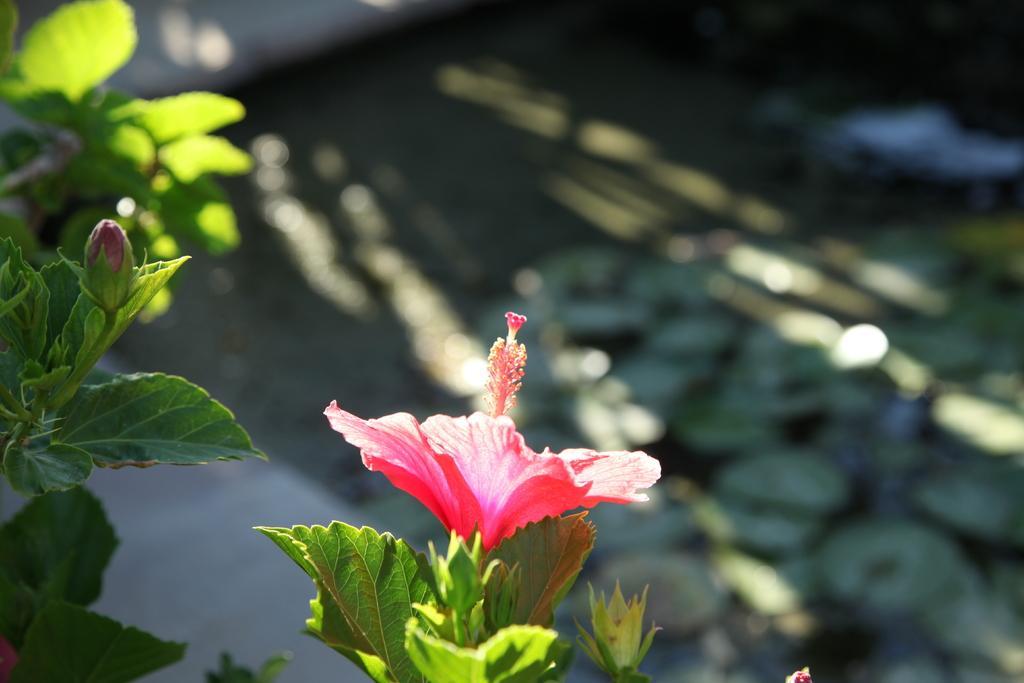Can you describe this image briefly? In the picture we can see some plants with a flower to it which is red in color and we can also see a flower bud and behind it we can see some plants which are not clearly visible. 